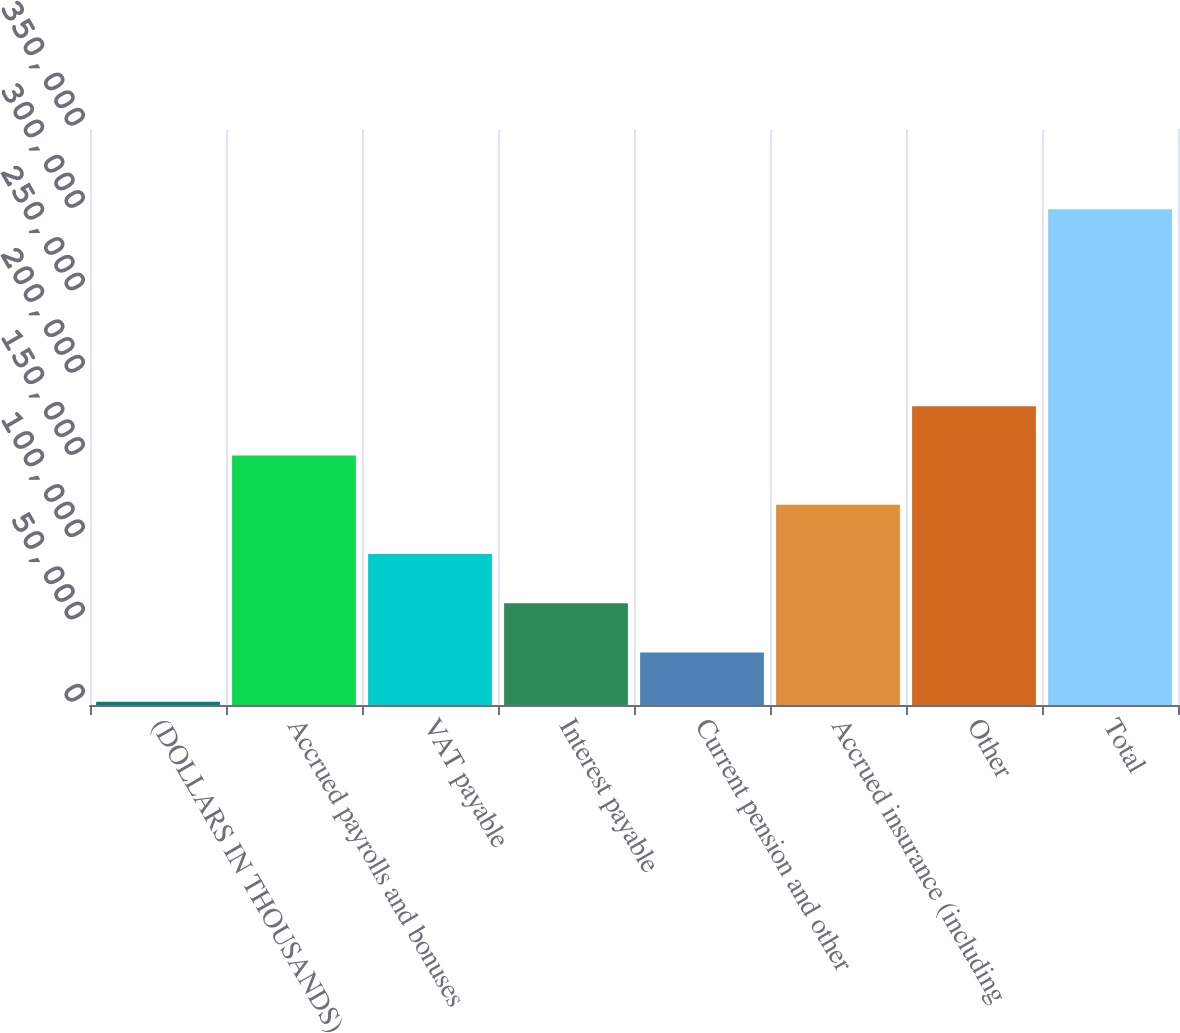<chart> <loc_0><loc_0><loc_500><loc_500><bar_chart><fcel>(DOLLARS IN THOUSANDS)<fcel>Accrued payrolls and bonuses<fcel>VAT payable<fcel>Interest payable<fcel>Current pension and other<fcel>Accrued insurance (including<fcel>Other<fcel>Total<nl><fcel>2010<fcel>151638<fcel>91786.5<fcel>61861<fcel>31935.5<fcel>121712<fcel>181563<fcel>301265<nl></chart> 